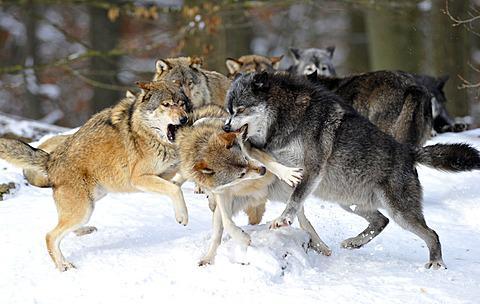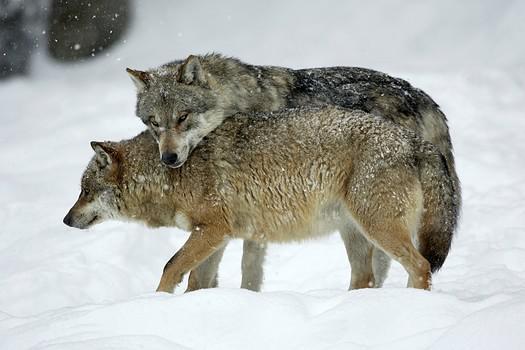The first image is the image on the left, the second image is the image on the right. Analyze the images presented: Is the assertion "The right image contains exactly two wolves." valid? Answer yes or no. Yes. The first image is the image on the left, the second image is the image on the right. Evaluate the accuracy of this statement regarding the images: "One image shows a single wolf in confrontation with a group of wolves that outnumber it about 5-to1.". Is it true? Answer yes or no. Yes. 